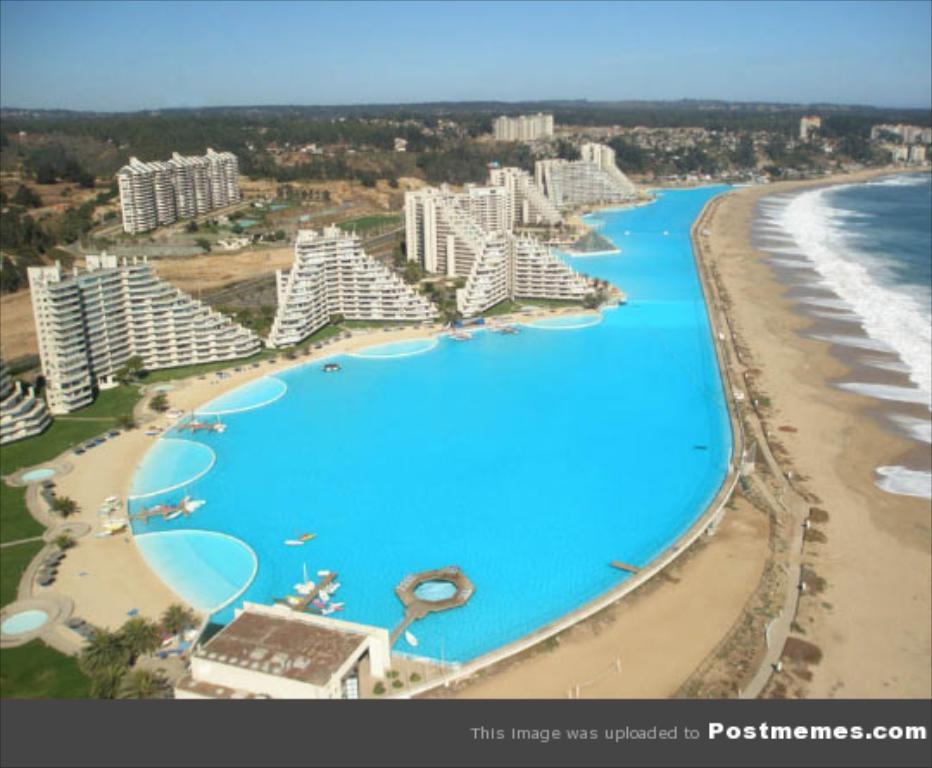What color is the water in the image? The water in the image is blue. What can be seen in the background of the image? There are buildings and trees in the background of the image. What color are the buildings in the image? The buildings in the image are white. What color are the trees in the image? The trees in the image are green. What color is the sky in the image? The sky in the image is blue. Where are the trousers located in the image? There are no trousers present in the image. What type of plastic object can be seen in the image? There is no plastic object present in the image. 